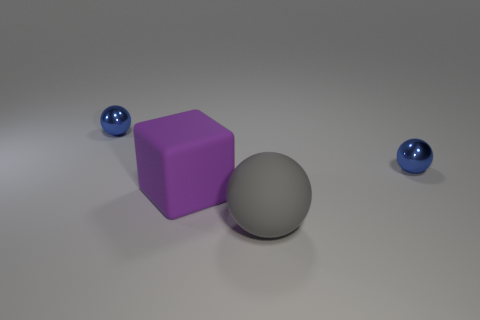Add 1 tiny things. How many objects exist? 5 Subtract all blue spheres. How many spheres are left? 1 Subtract all blue spheres. How many spheres are left? 1 Subtract 0 brown cylinders. How many objects are left? 4 Subtract all balls. How many objects are left? 1 Subtract 2 balls. How many balls are left? 1 Subtract all gray blocks. Subtract all red spheres. How many blocks are left? 1 Subtract all brown spheres. How many gray blocks are left? 0 Subtract all blue cylinders. Subtract all big gray rubber spheres. How many objects are left? 3 Add 2 spheres. How many spheres are left? 5 